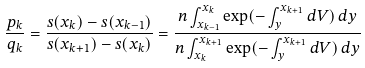Convert formula to latex. <formula><loc_0><loc_0><loc_500><loc_500>\frac { p _ { k } } { q _ { k } } = \frac { s ( x _ { k } ) - s ( x _ { k - 1 } ) } { s ( x _ { k + 1 } ) - s ( x _ { k } ) } = \frac { n \int _ { x _ { k - 1 } } ^ { x _ { k } } \exp ( - \int _ { y } ^ { x _ { k + 1 } } d V ) \, d y } { n \int _ { x _ { k } } ^ { x _ { k + 1 } } \exp ( - \int _ { y } ^ { x _ { k + 1 } } d V ) \, d y }</formula> 